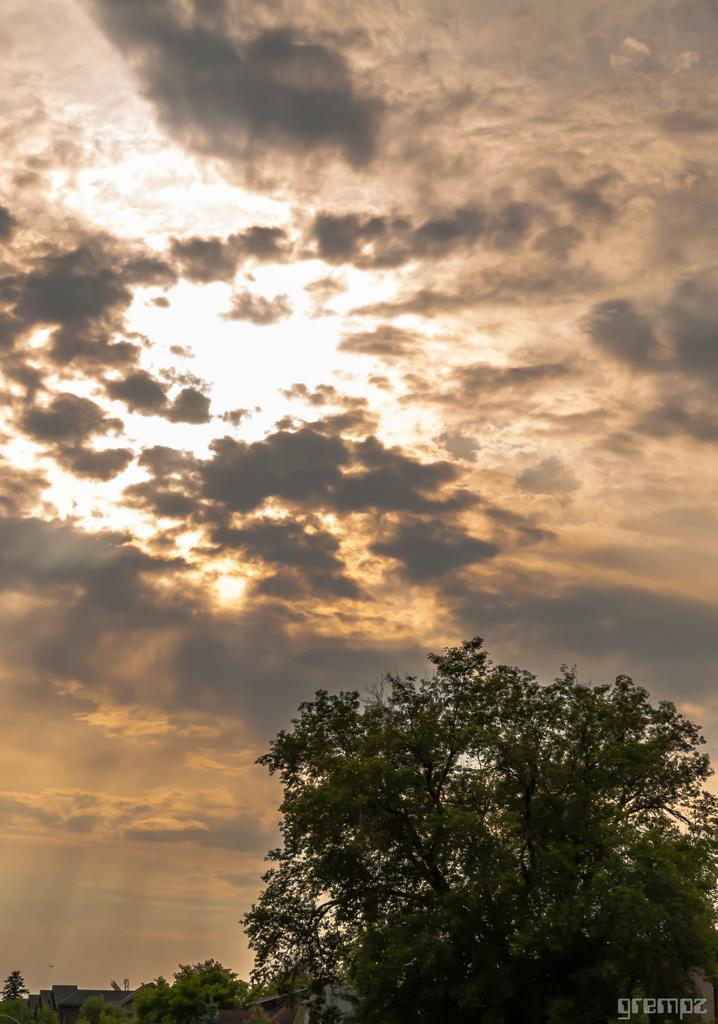What is located in the front of the image? There is a tree in the front of the image. What is visible in the background of the image? The sky is visible in the image. What can be seen in the sky? There are clouds in the sky. How many legs can be seen on the tree in the image? Trees do not have legs, so this question is not applicable to the image. What type of straw is being used to drink from the tree in the image? There is no straw present in the image, as trees do not require straws for any purpose. 